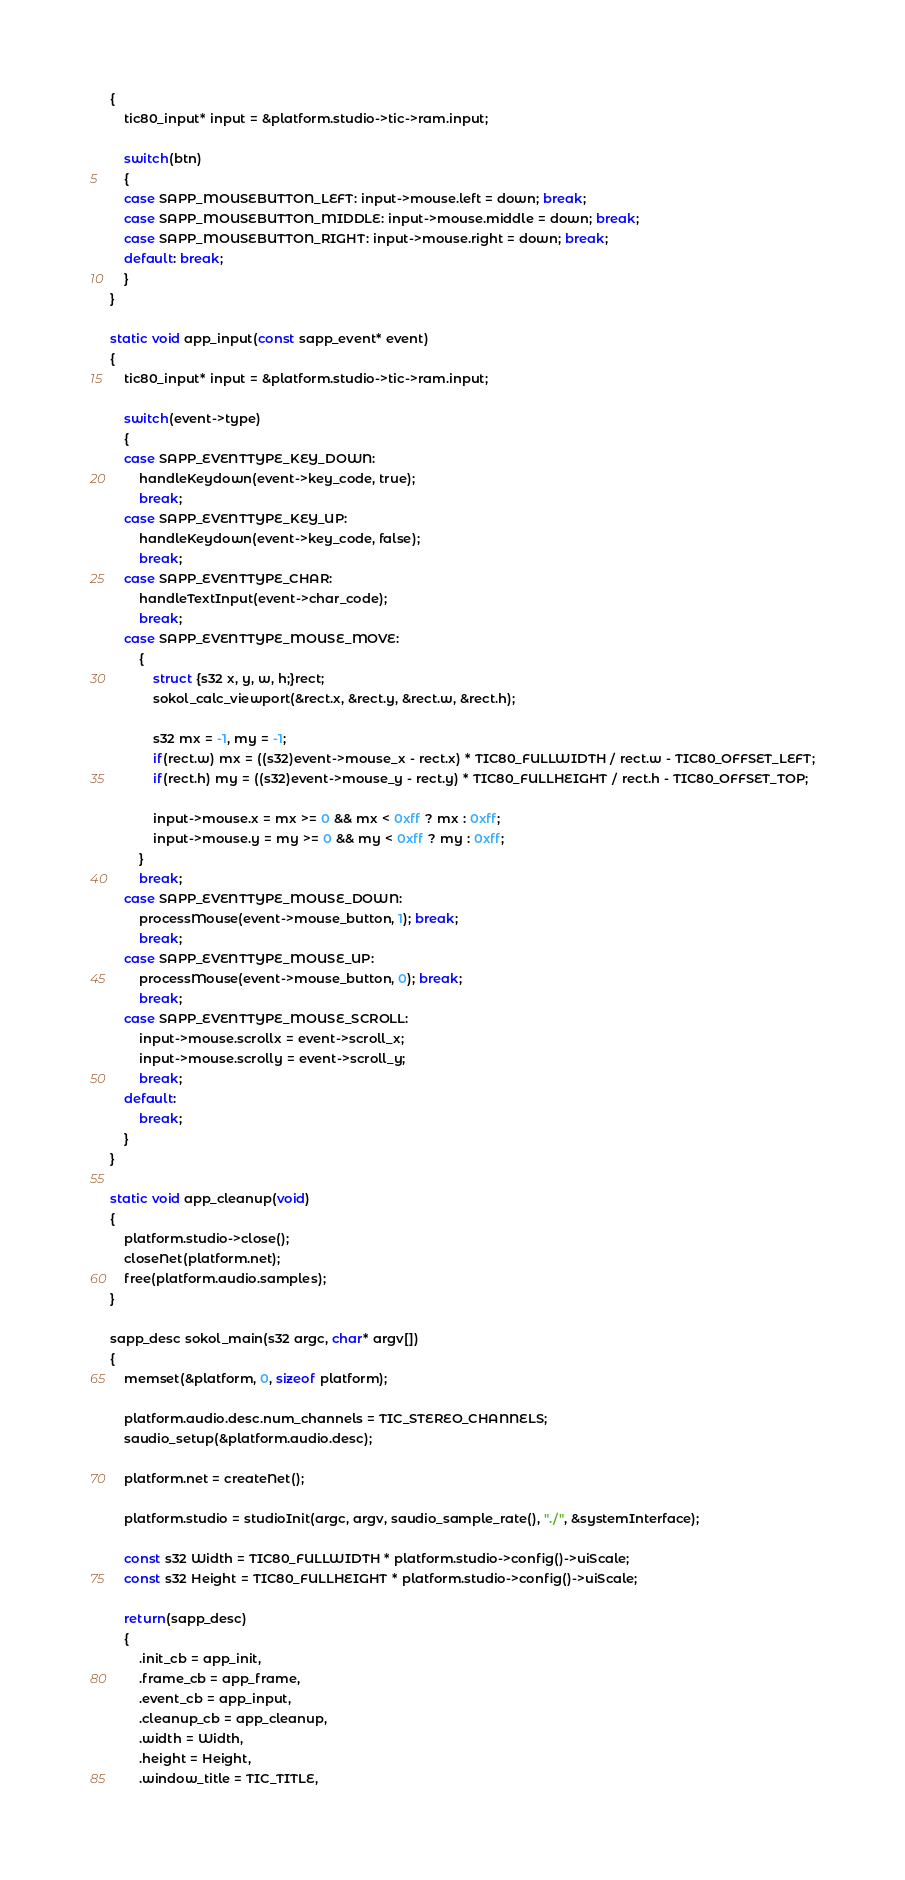Convert code to text. <code><loc_0><loc_0><loc_500><loc_500><_C_>{
	tic80_input* input = &platform.studio->tic->ram.input;

	switch(btn)
	{
	case SAPP_MOUSEBUTTON_LEFT: input->mouse.left = down; break;
	case SAPP_MOUSEBUTTON_MIDDLE: input->mouse.middle = down; break;
	case SAPP_MOUSEBUTTON_RIGHT: input->mouse.right = down; break;
	default: break;
	}
}

static void app_input(const sapp_event* event)
{
	tic80_input* input = &platform.studio->tic->ram.input;

	switch(event->type)
	{
	case SAPP_EVENTTYPE_KEY_DOWN:
		handleKeydown(event->key_code, true);
		break;
	case SAPP_EVENTTYPE_KEY_UP:
		handleKeydown(event->key_code, false);
		break;
	case SAPP_EVENTTYPE_CHAR:
		handleTextInput(event->char_code);
		break;
	case SAPP_EVENTTYPE_MOUSE_MOVE:
		{
			struct {s32 x, y, w, h;}rect;
    		sokol_calc_viewport(&rect.x, &rect.y, &rect.w, &rect.h);

    		s32 mx = -1, my = -1;
			if(rect.w) mx = ((s32)event->mouse_x - rect.x) * TIC80_FULLWIDTH / rect.w - TIC80_OFFSET_LEFT;
			if(rect.h) my = ((s32)event->mouse_y - rect.y) * TIC80_FULLHEIGHT / rect.h - TIC80_OFFSET_TOP;

			input->mouse.x = mx >= 0 && mx < 0xff ? mx : 0xff;
			input->mouse.y = my >= 0 && my < 0xff ? my : 0xff;
		}
		break;
	case SAPP_EVENTTYPE_MOUSE_DOWN: 
		processMouse(event->mouse_button, 1); break;
		break;
	case SAPP_EVENTTYPE_MOUSE_UP:
		processMouse(event->mouse_button, 0); break;
		break;
	case SAPP_EVENTTYPE_MOUSE_SCROLL:
		input->mouse.scrollx = event->scroll_x;
		input->mouse.scrolly = event->scroll_y;
		break;
	default:
		break;
	}
}

static void app_cleanup(void)
{
	platform.studio->close();
	closeNet(platform.net);
	free(platform.audio.samples);
}

sapp_desc sokol_main(s32 argc, char* argv[])
{
	memset(&platform, 0, sizeof platform);

	platform.audio.desc.num_channels = TIC_STEREO_CHANNELS;
	saudio_setup(&platform.audio.desc);

    platform.net = createNet();

	platform.studio = studioInit(argc, argv, saudio_sample_rate(), "./", &systemInterface);

	const s32 Width = TIC80_FULLWIDTH * platform.studio->config()->uiScale;
	const s32 Height = TIC80_FULLHEIGHT * platform.studio->config()->uiScale;

	return(sapp_desc)
	{
		.init_cb = app_init,
		.frame_cb = app_frame,
		.event_cb = app_input,
		.cleanup_cb = app_cleanup,
		.width = Width,
		.height = Height,
		.window_title = TIC_TITLE,</code> 